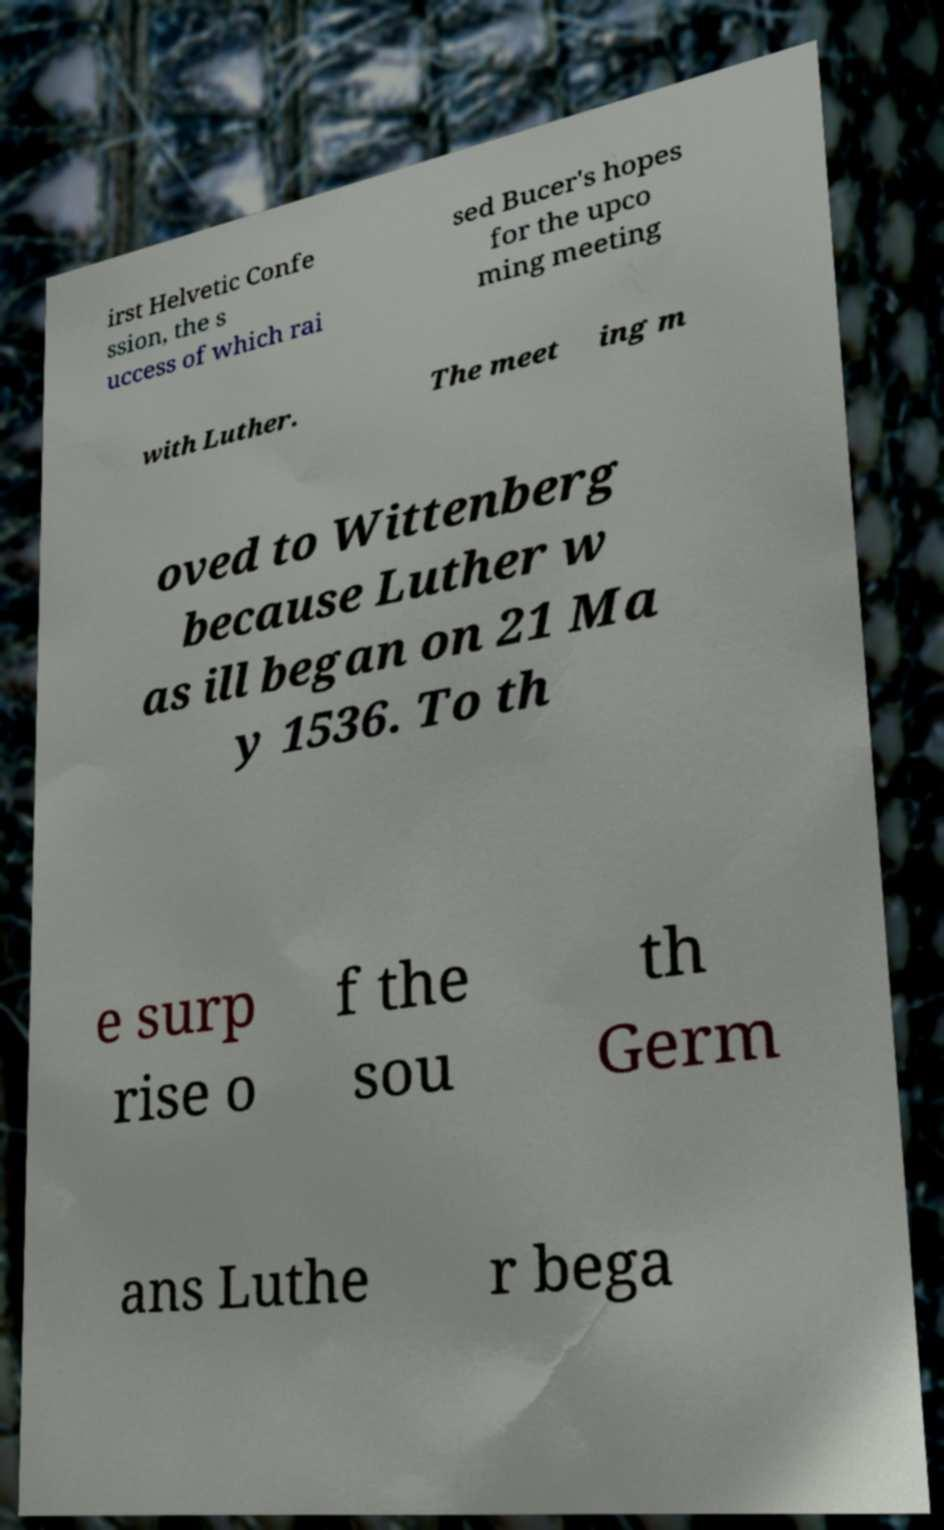There's text embedded in this image that I need extracted. Can you transcribe it verbatim? irst Helvetic Confe ssion, the s uccess of which rai sed Bucer's hopes for the upco ming meeting with Luther. The meet ing m oved to Wittenberg because Luther w as ill began on 21 Ma y 1536. To th e surp rise o f the sou th Germ ans Luthe r bega 